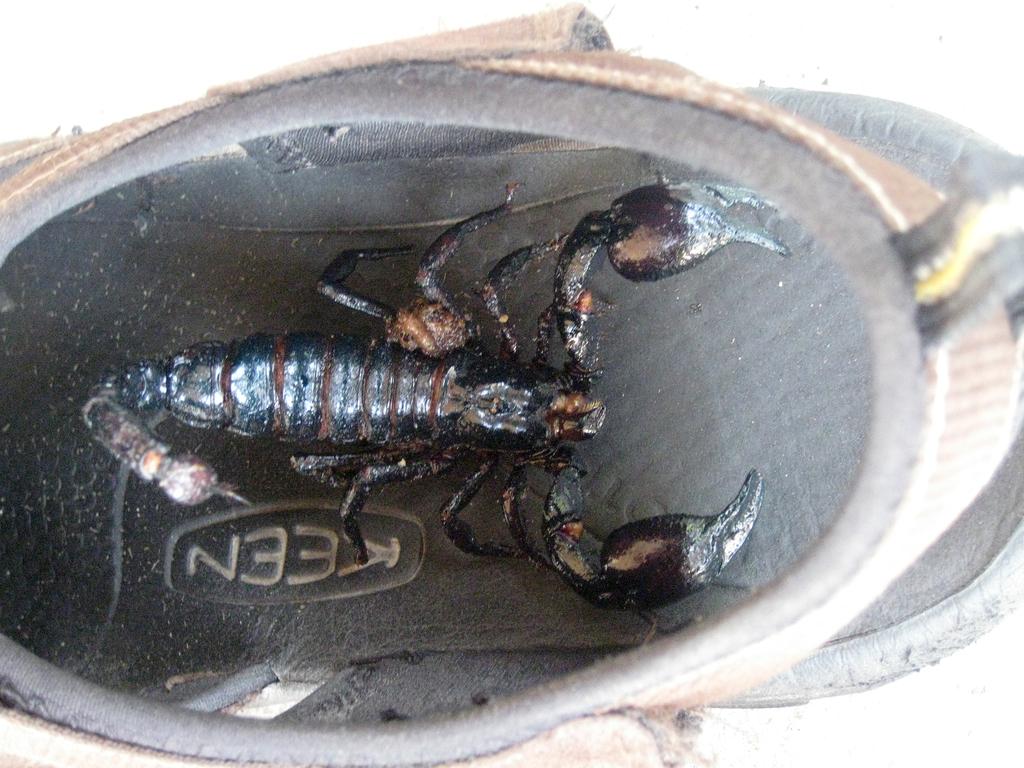What logois undernearth the scorpion?
Your response must be concise. Keen. 